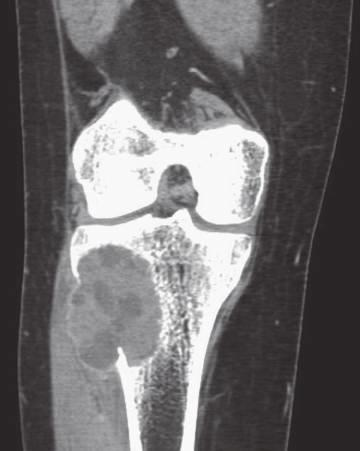s the right ventricle delineated by a thin rim of reactive subperiosteal bone?
Answer the question using a single word or phrase. No 